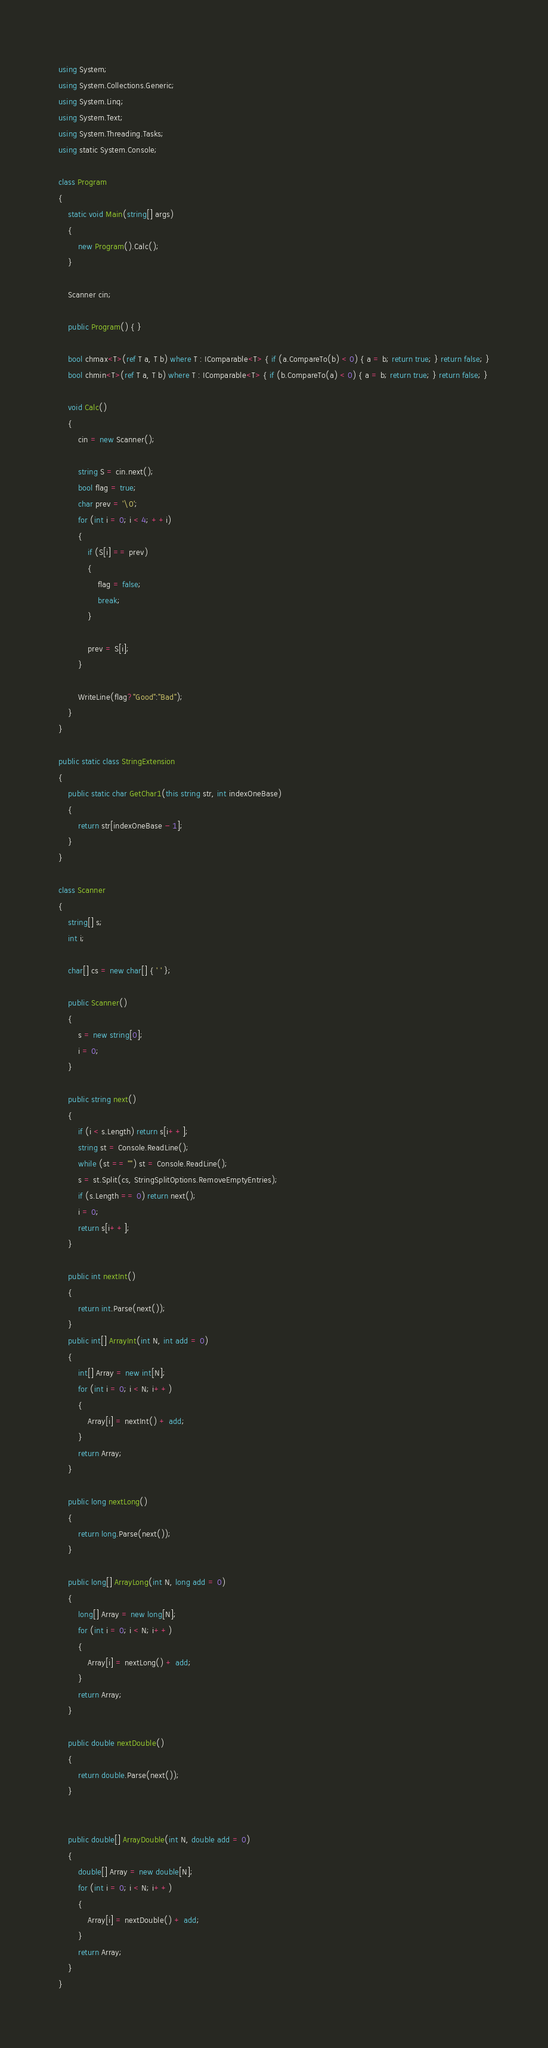Convert code to text. <code><loc_0><loc_0><loc_500><loc_500><_C#_>using System;
using System.Collections.Generic;
using System.Linq;
using System.Text;
using System.Threading.Tasks;
using static System.Console;

class Program
{
    static void Main(string[] args)
    {
        new Program().Calc();
    }

    Scanner cin;

    public Program() { }

    bool chmax<T>(ref T a, T b) where T : IComparable<T> { if (a.CompareTo(b) < 0) { a = b; return true; } return false; }
    bool chmin<T>(ref T a, T b) where T : IComparable<T> { if (b.CompareTo(a) < 0) { a = b; return true; } return false; }

    void Calc()
    {
        cin = new Scanner();

        string S = cin.next();
        bool flag = true;
        char prev = '\0';
        for (int i = 0; i < 4; ++i)
        {
            if (S[i] == prev)
            {
                flag = false;
                break;
            }

            prev = S[i];
        }

        WriteLine(flag?"Good":"Bad");
    }
}

public static class StringExtension
{
    public static char GetChar1(this string str, int indexOneBase)
    {
        return str[indexOneBase - 1];
    }
}

class Scanner
{
    string[] s;
    int i;

    char[] cs = new char[] { ' ' };

    public Scanner()
    {
        s = new string[0];
        i = 0;
    }

    public string next()
    {
        if (i < s.Length) return s[i++];
        string st = Console.ReadLine();
        while (st == "") st = Console.ReadLine();
        s = st.Split(cs, StringSplitOptions.RemoveEmptyEntries);
        if (s.Length == 0) return next();
        i = 0;
        return s[i++];
    }

    public int nextInt()
    {
        return int.Parse(next());
    }
    public int[] ArrayInt(int N, int add = 0)
    {
        int[] Array = new int[N];
        for (int i = 0; i < N; i++)
        {
            Array[i] = nextInt() + add;
        }
        return Array;
    }

    public long nextLong()
    {
        return long.Parse(next());
    }

    public long[] ArrayLong(int N, long add = 0)
    {
        long[] Array = new long[N];
        for (int i = 0; i < N; i++)
        {
            Array[i] = nextLong() + add;
        }
        return Array;
    }

    public double nextDouble()
    {
        return double.Parse(next());
    }


    public double[] ArrayDouble(int N, double add = 0)
    {
        double[] Array = new double[N];
        for (int i = 0; i < N; i++)
        {
            Array[i] = nextDouble() + add;
        }
        return Array;
    }
}
</code> 